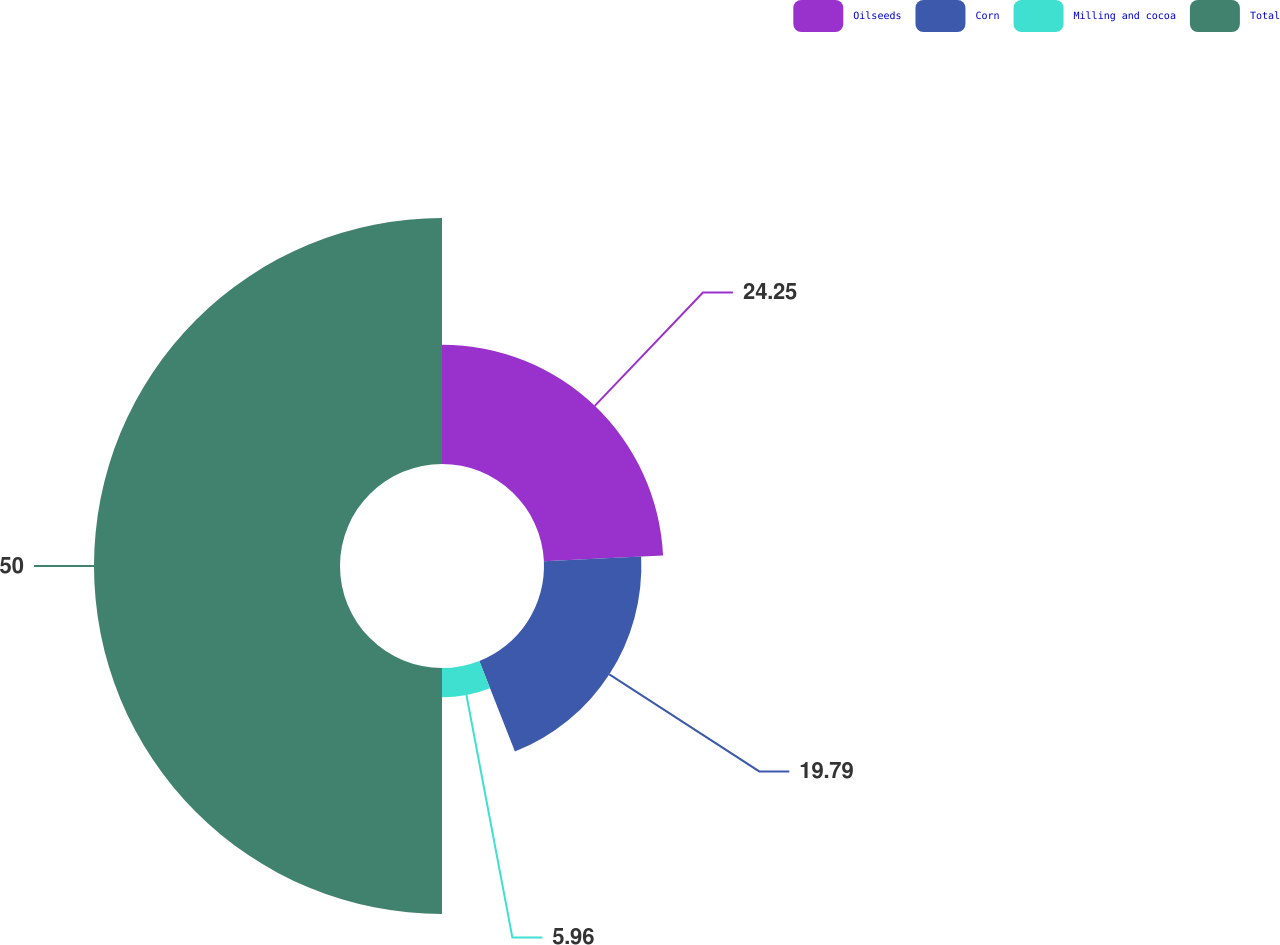Convert chart. <chart><loc_0><loc_0><loc_500><loc_500><pie_chart><fcel>Oilseeds<fcel>Corn<fcel>Milling and cocoa<fcel>Total<nl><fcel>24.25%<fcel>19.79%<fcel>5.96%<fcel>50.0%<nl></chart> 